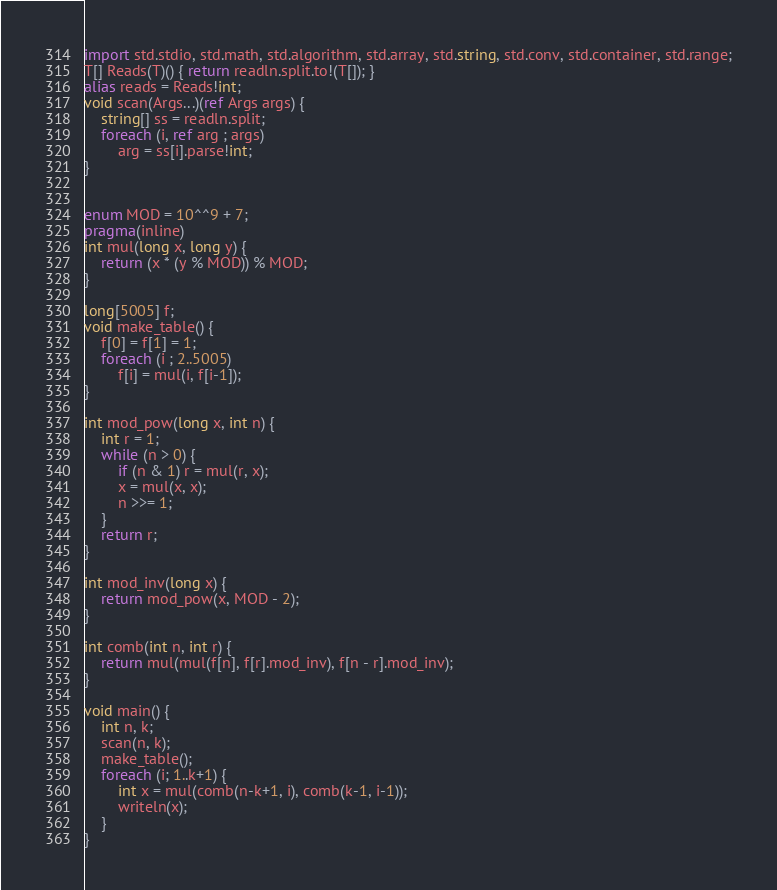Convert code to text. <code><loc_0><loc_0><loc_500><loc_500><_D_>import std.stdio, std.math, std.algorithm, std.array, std.string, std.conv, std.container, std.range;
T[] Reads(T)() { return readln.split.to!(T[]); }
alias reads = Reads!int;
void scan(Args...)(ref Args args) {
    string[] ss = readln.split;
    foreach (i, ref arg ; args)
        arg = ss[i].parse!int;
}


enum MOD = 10^^9 + 7;
pragma(inline)
int mul(long x, long y) {
    return (x * (y % MOD)) % MOD;
}

long[5005] f;
void make_table() {
    f[0] = f[1] = 1;
    foreach (i ; 2..5005)
        f[i] = mul(i, f[i-1]);
}

int mod_pow(long x, int n) {
    int r = 1;
    while (n > 0) {
        if (n & 1) r = mul(r, x);
        x = mul(x, x);
        n >>= 1;
    }
    return r;
}

int mod_inv(long x) {
    return mod_pow(x, MOD - 2);
}

int comb(int n, int r) {
    return mul(mul(f[n], f[r].mod_inv), f[n - r].mod_inv);
}

void main() {
    int n, k;
    scan(n, k);
    make_table();
    foreach (i; 1..k+1) {
        int x = mul(comb(n-k+1, i), comb(k-1, i-1));
        writeln(x);
    }
}</code> 